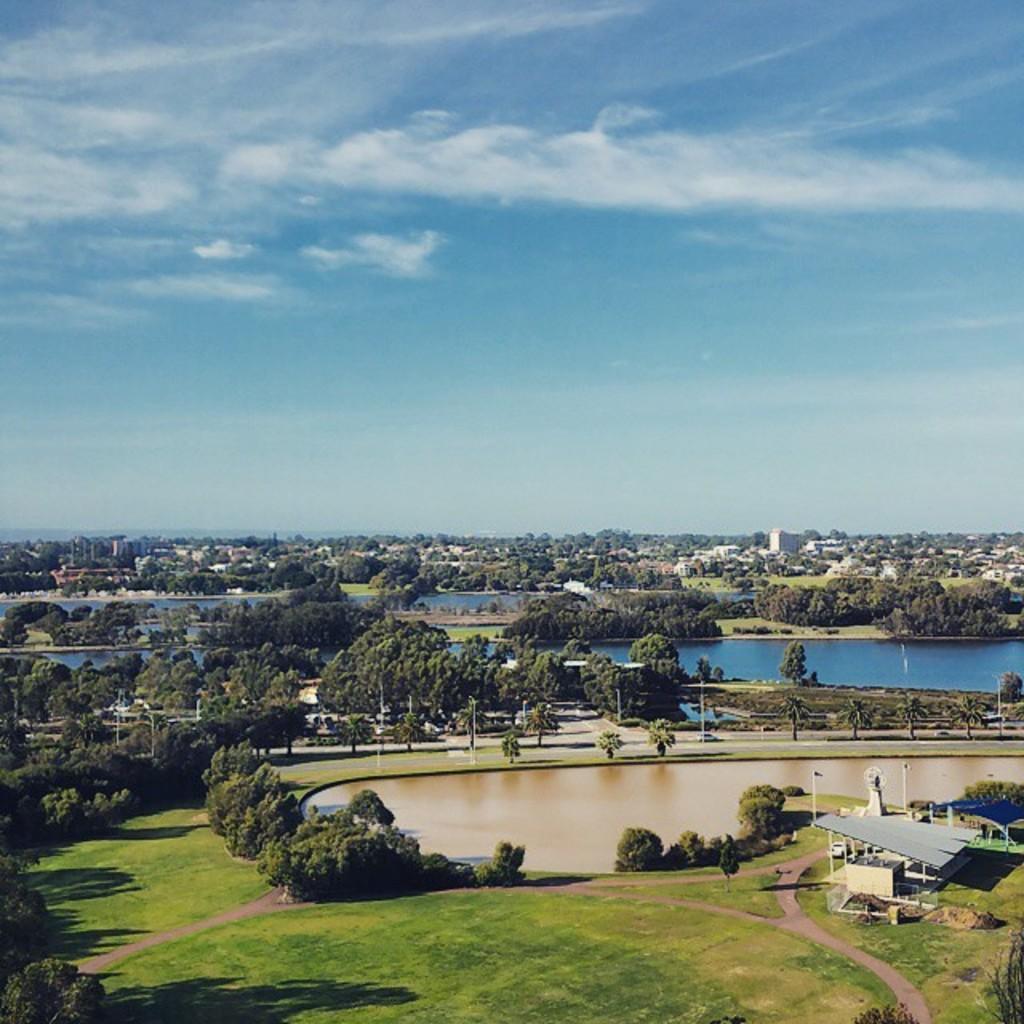In one or two sentences, can you explain what this image depicts? It is the top view of some area,it is filled with many plants and grass and there are two lakes in the image. In the background there are many buildings and houses in between the trees. 